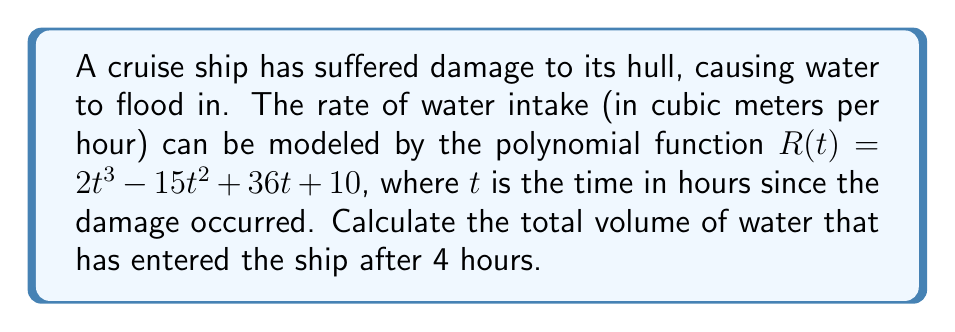Provide a solution to this math problem. To find the total volume of water that has entered the ship after 4 hours, we need to calculate the definite integral of the rate function $R(t)$ from $t=0$ to $t=4$. This will give us the area under the curve of the rate function, which represents the total volume of water.

Let's follow these steps:

1) The indefinite integral of $R(t)$ is:

   $$\int R(t) dt = \int (2t^3 - 15t^2 + 36t + 10) dt$$
   $$= \frac{1}{2}t^4 - 5t^3 + 18t^2 + 10t + C$$

2) We'll call this antiderivative $V(t)$:

   $$V(t) = \frac{1}{2}t^4 - 5t^3 + 18t^2 + 10t$$

3) To find the definite integral from 0 to 4, we calculate $V(4) - V(0)$:

   $$V(4) = \frac{1}{2}(4^4) - 5(4^3) + 18(4^2) + 10(4)$$
   $$= 128 - 320 + 288 + 40 = 136$$

   $$V(0) = \frac{1}{2}(0^4) - 5(0^3) + 18(0^2) + 10(0) = 0$$

4) Therefore, the total volume is:

   $$V(4) - V(0) = 136 - 0 = 136$$

Thus, the total volume of water that has entered the ship after 4 hours is 136 cubic meters.
Answer: 136 cubic meters 